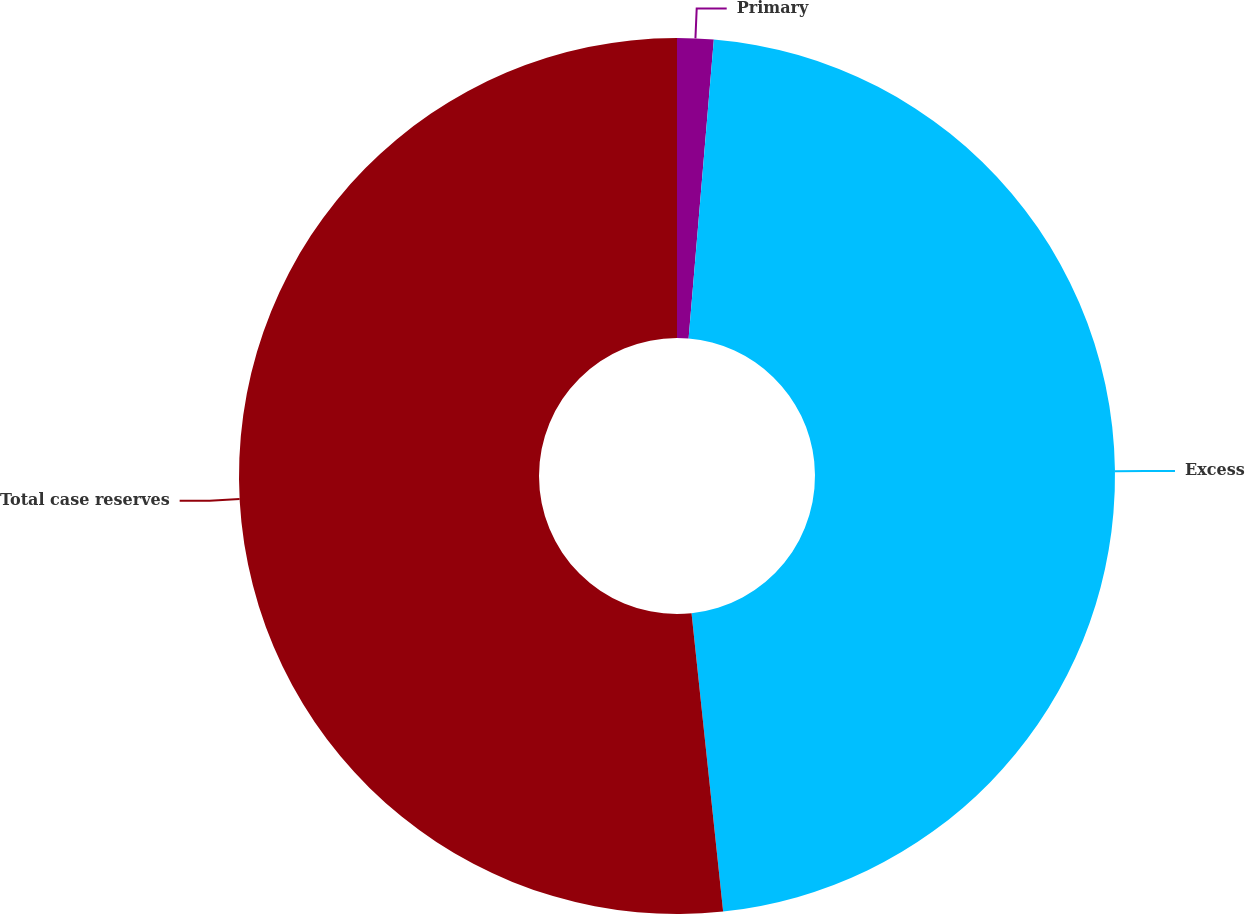Convert chart. <chart><loc_0><loc_0><loc_500><loc_500><pie_chart><fcel>Primary<fcel>Excess<fcel>Total case reserves<nl><fcel>1.34%<fcel>46.98%<fcel>51.68%<nl></chart> 